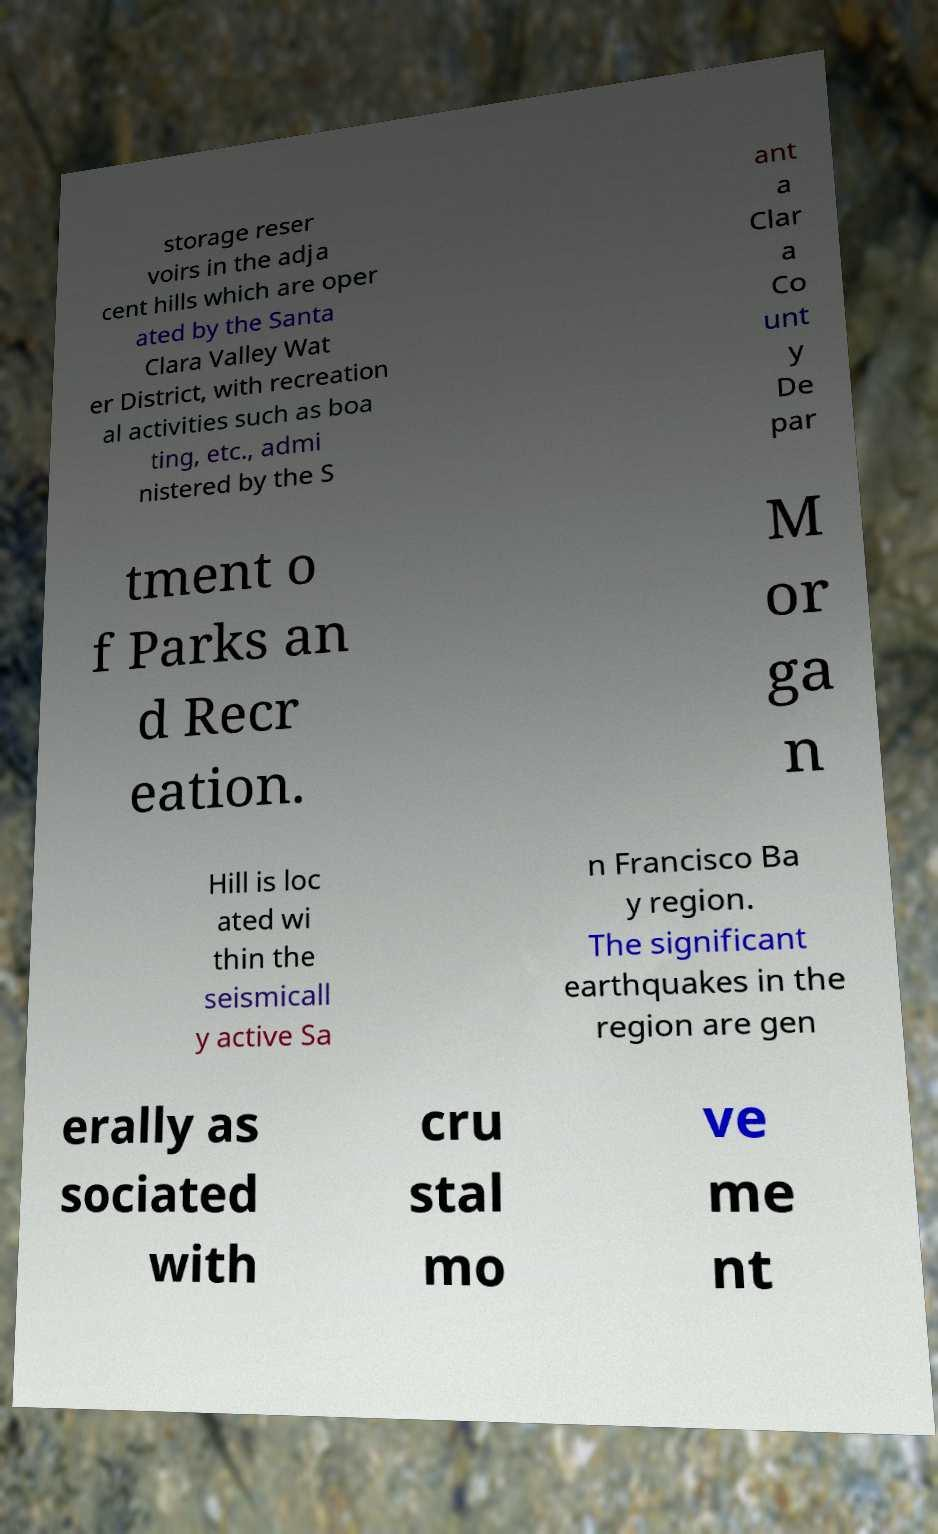Can you accurately transcribe the text from the provided image for me? storage reser voirs in the adja cent hills which are oper ated by the Santa Clara Valley Wat er District, with recreation al activities such as boa ting, etc., admi nistered by the S ant a Clar a Co unt y De par tment o f Parks an d Recr eation. M or ga n Hill is loc ated wi thin the seismicall y active Sa n Francisco Ba y region. The significant earthquakes in the region are gen erally as sociated with cru stal mo ve me nt 